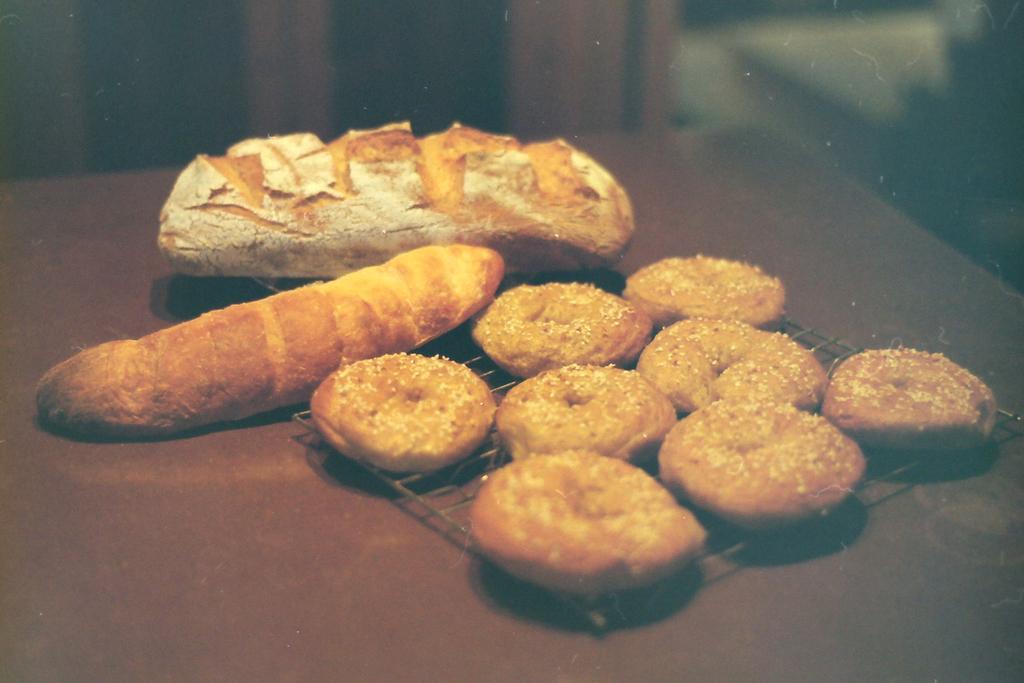Please provide a concise description of this image. In the image there are cookies and bread on a table. 